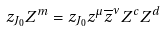Convert formula to latex. <formula><loc_0><loc_0><loc_500><loc_500>& z _ { J _ { 0 } } Z ^ { m } = z _ { J _ { 0 } } z ^ { \mu } \overline { z } ^ { \nu } Z ^ { c } Z ^ { d }</formula> 